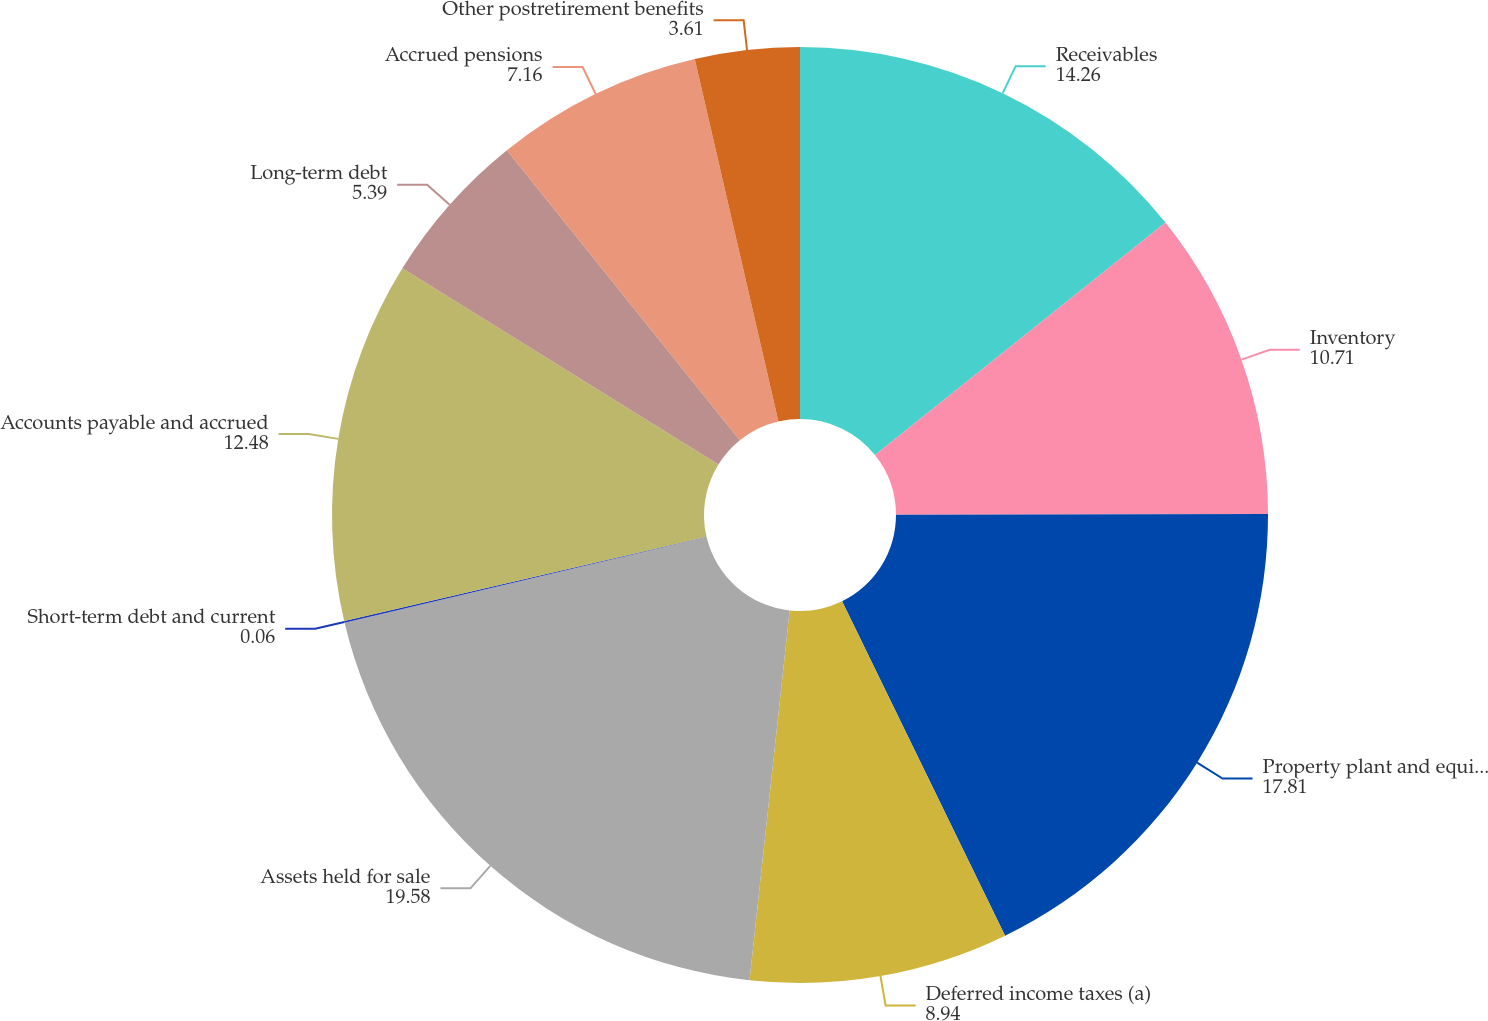<chart> <loc_0><loc_0><loc_500><loc_500><pie_chart><fcel>Receivables<fcel>Inventory<fcel>Property plant and equipment<fcel>Deferred income taxes (a)<fcel>Assets held for sale<fcel>Short-term debt and current<fcel>Accounts payable and accrued<fcel>Long-term debt<fcel>Accrued pensions<fcel>Other postretirement benefits<nl><fcel>14.26%<fcel>10.71%<fcel>17.81%<fcel>8.94%<fcel>19.58%<fcel>0.06%<fcel>12.48%<fcel>5.39%<fcel>7.16%<fcel>3.61%<nl></chart> 